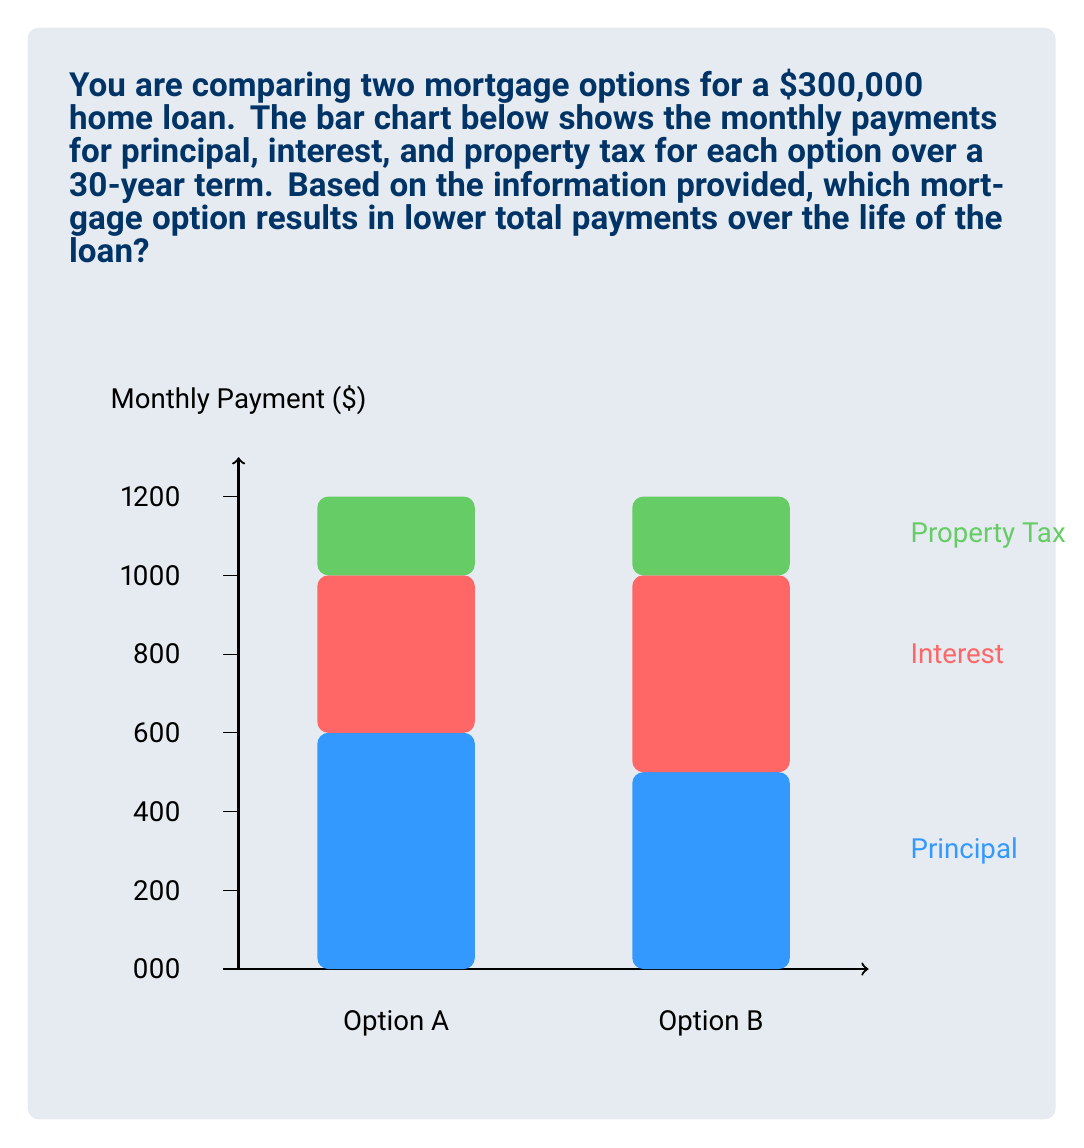Can you answer this question? To determine which mortgage option results in lower total payments over the life of the loan, we need to calculate the total monthly payment for each option and then multiply by the number of months in the loan term.

Step 1: Calculate monthly payments for Option A
Principal: $900
Interest: $600
Property Tax: $300
Total monthly payment A = $900 + $600 + $300 = $1800

Step 2: Calculate monthly payments for Option B
Principal: $750
Interest: $750
Property Tax: $300
Total monthly payment B = $750 + $750 + $300 = $1800

Step 3: Calculate total payments over the life of the loan
Number of months in 30 years = 30 * 12 = 360 months

Total payments for Option A = $1800 * 360 = $648,000
Total payments for Option B = $1800 * 360 = $648,000

Step 4: Compare total payments
Both options result in the same total payments over the life of the loan.

Step 5: Consider the distribution of payments
Although the total payments are the same, Option A allocates more towards the principal each month ($900 vs $750). This means that with Option A, you'll build equity in your home faster and pay less in total interest over the life of the loan.

Therefore, while the total payments are equal, Option A is more advantageous due to the higher principal payments and lower interest payments.
Answer: Option A 